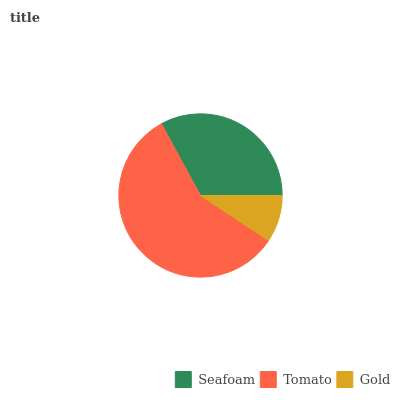Is Gold the minimum?
Answer yes or no. Yes. Is Tomato the maximum?
Answer yes or no. Yes. Is Tomato the minimum?
Answer yes or no. No. Is Gold the maximum?
Answer yes or no. No. Is Tomato greater than Gold?
Answer yes or no. Yes. Is Gold less than Tomato?
Answer yes or no. Yes. Is Gold greater than Tomato?
Answer yes or no. No. Is Tomato less than Gold?
Answer yes or no. No. Is Seafoam the high median?
Answer yes or no. Yes. Is Seafoam the low median?
Answer yes or no. Yes. Is Gold the high median?
Answer yes or no. No. Is Gold the low median?
Answer yes or no. No. 